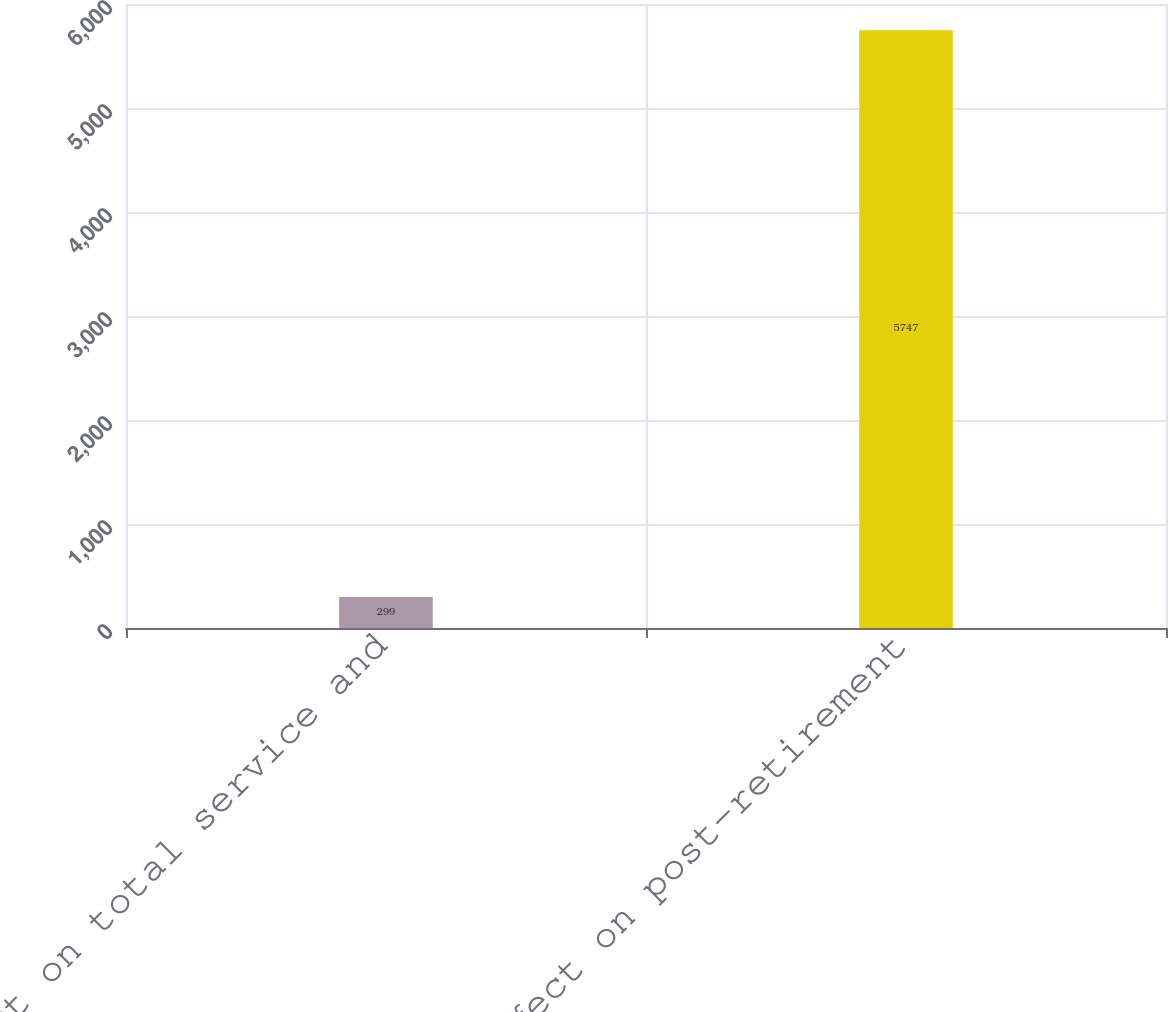Convert chart. <chart><loc_0><loc_0><loc_500><loc_500><bar_chart><fcel>Effect on total service and<fcel>Effect on post-retirement<nl><fcel>299<fcel>5747<nl></chart> 